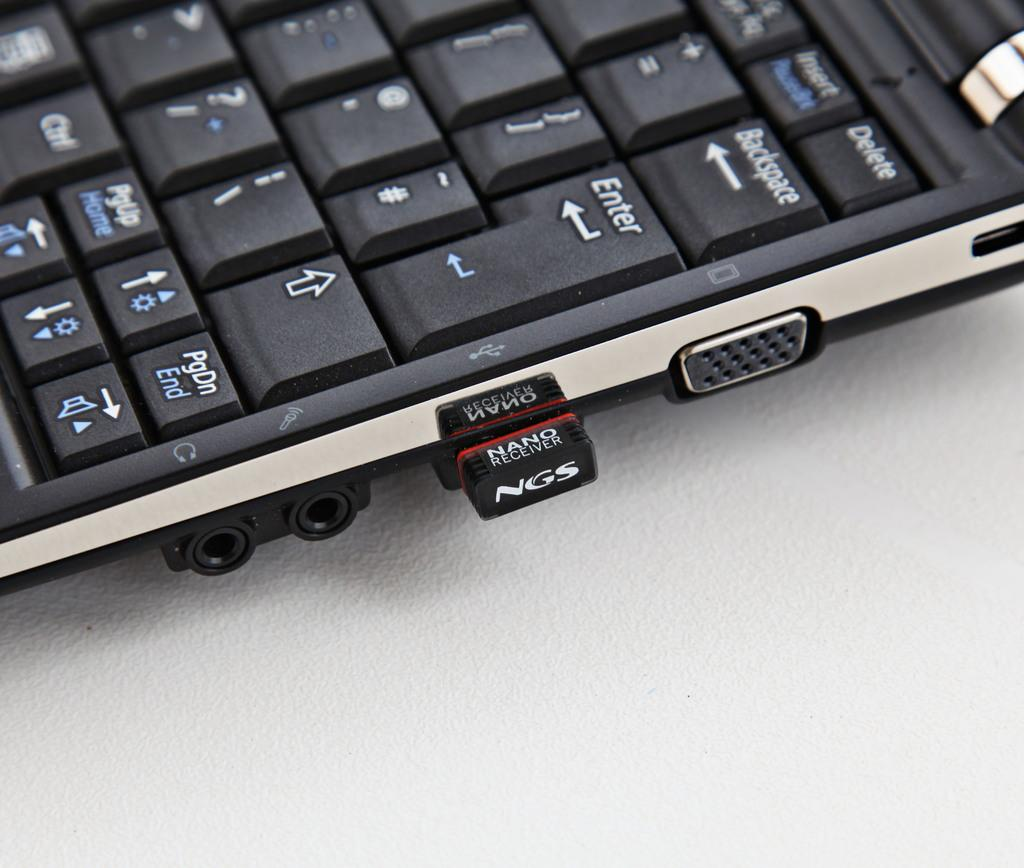What is the main object in the foreground of the image? There is a keyboard of a laptop in the foreground of the image. What can be seen near the laptop? There are ports visible near the laptop. What device is connected to the laptop? A receiver is connected to the laptop. What type of lipstick is being used on the flag in the image? There is no lipstick or flag present in the image; it features a laptop with a keyboard, ports, and a connected receiver. 